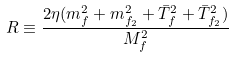Convert formula to latex. <formula><loc_0><loc_0><loc_500><loc_500>R \equiv \frac { 2 \eta ( m _ { f } ^ { 2 } + m _ { f _ { 2 } } ^ { 2 } + \bar { T } _ { f } ^ { 2 } + \bar { T } _ { f _ { 2 } } ^ { 2 } ) } { M _ { f } ^ { 2 } }</formula> 